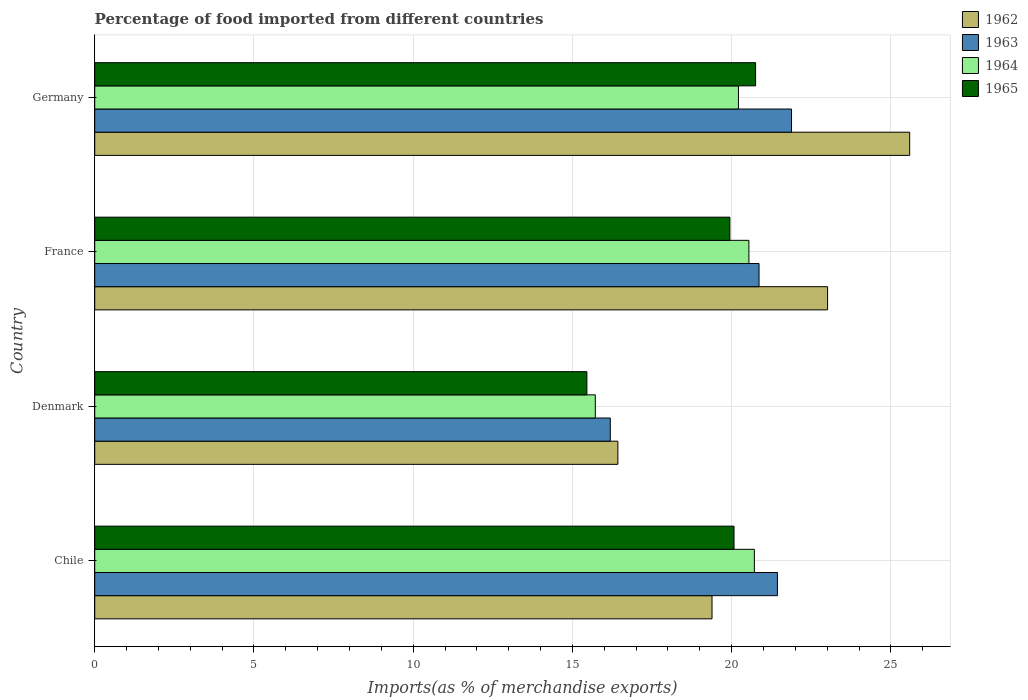Are the number of bars per tick equal to the number of legend labels?
Provide a succinct answer. Yes. Are the number of bars on each tick of the Y-axis equal?
Ensure brevity in your answer.  Yes. What is the label of the 4th group of bars from the top?
Ensure brevity in your answer.  Chile. What is the percentage of imports to different countries in 1964 in Germany?
Your answer should be compact. 20.21. Across all countries, what is the maximum percentage of imports to different countries in 1963?
Give a very brief answer. 21.88. Across all countries, what is the minimum percentage of imports to different countries in 1962?
Give a very brief answer. 16.43. In which country was the percentage of imports to different countries in 1962 minimum?
Keep it short and to the point. Denmark. What is the total percentage of imports to different countries in 1964 in the graph?
Offer a terse response. 77.18. What is the difference between the percentage of imports to different countries in 1964 in Chile and that in Denmark?
Provide a short and direct response. 4.99. What is the difference between the percentage of imports to different countries in 1963 in Chile and the percentage of imports to different countries in 1964 in Germany?
Your answer should be compact. 1.22. What is the average percentage of imports to different countries in 1963 per country?
Ensure brevity in your answer.  20.09. What is the difference between the percentage of imports to different countries in 1964 and percentage of imports to different countries in 1965 in Germany?
Your answer should be compact. -0.54. In how many countries, is the percentage of imports to different countries in 1962 greater than 13 %?
Provide a succinct answer. 4. What is the ratio of the percentage of imports to different countries in 1962 in Denmark to that in Germany?
Provide a short and direct response. 0.64. Is the difference between the percentage of imports to different countries in 1964 in Chile and Denmark greater than the difference between the percentage of imports to different countries in 1965 in Chile and Denmark?
Give a very brief answer. Yes. What is the difference between the highest and the second highest percentage of imports to different countries in 1962?
Keep it short and to the point. 2.58. What is the difference between the highest and the lowest percentage of imports to different countries in 1963?
Your answer should be very brief. 5.69. In how many countries, is the percentage of imports to different countries in 1963 greater than the average percentage of imports to different countries in 1963 taken over all countries?
Make the answer very short. 3. What does the 4th bar from the top in Germany represents?
Give a very brief answer. 1962. What does the 3rd bar from the bottom in Denmark represents?
Ensure brevity in your answer.  1964. Are all the bars in the graph horizontal?
Give a very brief answer. Yes. How many countries are there in the graph?
Offer a very short reply. 4. What is the difference between two consecutive major ticks on the X-axis?
Make the answer very short. 5. Where does the legend appear in the graph?
Offer a terse response. Top right. How many legend labels are there?
Provide a short and direct response. 4. How are the legend labels stacked?
Make the answer very short. Vertical. What is the title of the graph?
Your response must be concise. Percentage of food imported from different countries. What is the label or title of the X-axis?
Your response must be concise. Imports(as % of merchandise exports). What is the label or title of the Y-axis?
Your answer should be compact. Country. What is the Imports(as % of merchandise exports) in 1962 in Chile?
Give a very brief answer. 19.38. What is the Imports(as % of merchandise exports) of 1963 in Chile?
Offer a terse response. 21.44. What is the Imports(as % of merchandise exports) in 1964 in Chile?
Make the answer very short. 20.71. What is the Imports(as % of merchandise exports) in 1965 in Chile?
Offer a very short reply. 20.07. What is the Imports(as % of merchandise exports) of 1962 in Denmark?
Provide a short and direct response. 16.43. What is the Imports(as % of merchandise exports) of 1963 in Denmark?
Your answer should be compact. 16.19. What is the Imports(as % of merchandise exports) in 1964 in Denmark?
Keep it short and to the point. 15.72. What is the Imports(as % of merchandise exports) in 1965 in Denmark?
Your answer should be very brief. 15.45. What is the Imports(as % of merchandise exports) in 1962 in France?
Make the answer very short. 23.01. What is the Imports(as % of merchandise exports) in 1963 in France?
Provide a short and direct response. 20.86. What is the Imports(as % of merchandise exports) of 1964 in France?
Make the answer very short. 20.54. What is the Imports(as % of merchandise exports) of 1965 in France?
Your response must be concise. 19.94. What is the Imports(as % of merchandise exports) of 1962 in Germany?
Provide a short and direct response. 25.59. What is the Imports(as % of merchandise exports) of 1963 in Germany?
Give a very brief answer. 21.88. What is the Imports(as % of merchandise exports) of 1964 in Germany?
Your answer should be compact. 20.21. What is the Imports(as % of merchandise exports) of 1965 in Germany?
Your answer should be compact. 20.75. Across all countries, what is the maximum Imports(as % of merchandise exports) in 1962?
Ensure brevity in your answer.  25.59. Across all countries, what is the maximum Imports(as % of merchandise exports) in 1963?
Your answer should be very brief. 21.88. Across all countries, what is the maximum Imports(as % of merchandise exports) of 1964?
Provide a succinct answer. 20.71. Across all countries, what is the maximum Imports(as % of merchandise exports) of 1965?
Keep it short and to the point. 20.75. Across all countries, what is the minimum Imports(as % of merchandise exports) in 1962?
Your answer should be very brief. 16.43. Across all countries, what is the minimum Imports(as % of merchandise exports) in 1963?
Give a very brief answer. 16.19. Across all countries, what is the minimum Imports(as % of merchandise exports) of 1964?
Keep it short and to the point. 15.72. Across all countries, what is the minimum Imports(as % of merchandise exports) in 1965?
Ensure brevity in your answer.  15.45. What is the total Imports(as % of merchandise exports) of 1962 in the graph?
Ensure brevity in your answer.  84.41. What is the total Imports(as % of merchandise exports) in 1963 in the graph?
Keep it short and to the point. 80.36. What is the total Imports(as % of merchandise exports) in 1964 in the graph?
Your answer should be compact. 77.18. What is the total Imports(as % of merchandise exports) of 1965 in the graph?
Offer a very short reply. 76.22. What is the difference between the Imports(as % of merchandise exports) in 1962 in Chile and that in Denmark?
Offer a terse response. 2.96. What is the difference between the Imports(as % of merchandise exports) of 1963 in Chile and that in Denmark?
Your response must be concise. 5.25. What is the difference between the Imports(as % of merchandise exports) in 1964 in Chile and that in Denmark?
Give a very brief answer. 4.99. What is the difference between the Imports(as % of merchandise exports) in 1965 in Chile and that in Denmark?
Your response must be concise. 4.62. What is the difference between the Imports(as % of merchandise exports) in 1962 in Chile and that in France?
Your answer should be compact. -3.63. What is the difference between the Imports(as % of merchandise exports) in 1963 in Chile and that in France?
Keep it short and to the point. 0.58. What is the difference between the Imports(as % of merchandise exports) in 1964 in Chile and that in France?
Provide a short and direct response. 0.17. What is the difference between the Imports(as % of merchandise exports) in 1965 in Chile and that in France?
Your answer should be compact. 0.13. What is the difference between the Imports(as % of merchandise exports) of 1962 in Chile and that in Germany?
Your answer should be compact. -6.21. What is the difference between the Imports(as % of merchandise exports) of 1963 in Chile and that in Germany?
Make the answer very short. -0.44. What is the difference between the Imports(as % of merchandise exports) of 1964 in Chile and that in Germany?
Your response must be concise. 0.5. What is the difference between the Imports(as % of merchandise exports) in 1965 in Chile and that in Germany?
Provide a succinct answer. -0.68. What is the difference between the Imports(as % of merchandise exports) of 1962 in Denmark and that in France?
Ensure brevity in your answer.  -6.59. What is the difference between the Imports(as % of merchandise exports) of 1963 in Denmark and that in France?
Provide a short and direct response. -4.67. What is the difference between the Imports(as % of merchandise exports) of 1964 in Denmark and that in France?
Your answer should be compact. -4.82. What is the difference between the Imports(as % of merchandise exports) in 1965 in Denmark and that in France?
Offer a very short reply. -4.49. What is the difference between the Imports(as % of merchandise exports) in 1962 in Denmark and that in Germany?
Provide a short and direct response. -9.16. What is the difference between the Imports(as % of merchandise exports) of 1963 in Denmark and that in Germany?
Your answer should be compact. -5.69. What is the difference between the Imports(as % of merchandise exports) of 1964 in Denmark and that in Germany?
Offer a very short reply. -4.49. What is the difference between the Imports(as % of merchandise exports) in 1965 in Denmark and that in Germany?
Your answer should be very brief. -5.3. What is the difference between the Imports(as % of merchandise exports) in 1962 in France and that in Germany?
Your answer should be compact. -2.58. What is the difference between the Imports(as % of merchandise exports) of 1963 in France and that in Germany?
Your answer should be very brief. -1.02. What is the difference between the Imports(as % of merchandise exports) of 1964 in France and that in Germany?
Give a very brief answer. 0.33. What is the difference between the Imports(as % of merchandise exports) in 1965 in France and that in Germany?
Ensure brevity in your answer.  -0.81. What is the difference between the Imports(as % of merchandise exports) in 1962 in Chile and the Imports(as % of merchandise exports) in 1963 in Denmark?
Keep it short and to the point. 3.19. What is the difference between the Imports(as % of merchandise exports) in 1962 in Chile and the Imports(as % of merchandise exports) in 1964 in Denmark?
Keep it short and to the point. 3.66. What is the difference between the Imports(as % of merchandise exports) of 1962 in Chile and the Imports(as % of merchandise exports) of 1965 in Denmark?
Your answer should be very brief. 3.93. What is the difference between the Imports(as % of merchandise exports) of 1963 in Chile and the Imports(as % of merchandise exports) of 1964 in Denmark?
Provide a succinct answer. 5.72. What is the difference between the Imports(as % of merchandise exports) in 1963 in Chile and the Imports(as % of merchandise exports) in 1965 in Denmark?
Give a very brief answer. 5.98. What is the difference between the Imports(as % of merchandise exports) in 1964 in Chile and the Imports(as % of merchandise exports) in 1965 in Denmark?
Offer a terse response. 5.26. What is the difference between the Imports(as % of merchandise exports) in 1962 in Chile and the Imports(as % of merchandise exports) in 1963 in France?
Keep it short and to the point. -1.48. What is the difference between the Imports(as % of merchandise exports) in 1962 in Chile and the Imports(as % of merchandise exports) in 1964 in France?
Give a very brief answer. -1.16. What is the difference between the Imports(as % of merchandise exports) of 1962 in Chile and the Imports(as % of merchandise exports) of 1965 in France?
Offer a very short reply. -0.56. What is the difference between the Imports(as % of merchandise exports) of 1963 in Chile and the Imports(as % of merchandise exports) of 1964 in France?
Provide a short and direct response. 0.9. What is the difference between the Imports(as % of merchandise exports) in 1963 in Chile and the Imports(as % of merchandise exports) in 1965 in France?
Your answer should be compact. 1.49. What is the difference between the Imports(as % of merchandise exports) in 1964 in Chile and the Imports(as % of merchandise exports) in 1965 in France?
Provide a succinct answer. 0.77. What is the difference between the Imports(as % of merchandise exports) of 1962 in Chile and the Imports(as % of merchandise exports) of 1963 in Germany?
Ensure brevity in your answer.  -2.5. What is the difference between the Imports(as % of merchandise exports) in 1962 in Chile and the Imports(as % of merchandise exports) in 1964 in Germany?
Make the answer very short. -0.83. What is the difference between the Imports(as % of merchandise exports) of 1962 in Chile and the Imports(as % of merchandise exports) of 1965 in Germany?
Make the answer very short. -1.37. What is the difference between the Imports(as % of merchandise exports) in 1963 in Chile and the Imports(as % of merchandise exports) in 1964 in Germany?
Give a very brief answer. 1.22. What is the difference between the Imports(as % of merchandise exports) in 1963 in Chile and the Imports(as % of merchandise exports) in 1965 in Germany?
Your answer should be compact. 0.69. What is the difference between the Imports(as % of merchandise exports) in 1964 in Chile and the Imports(as % of merchandise exports) in 1965 in Germany?
Give a very brief answer. -0.04. What is the difference between the Imports(as % of merchandise exports) in 1962 in Denmark and the Imports(as % of merchandise exports) in 1963 in France?
Keep it short and to the point. -4.43. What is the difference between the Imports(as % of merchandise exports) in 1962 in Denmark and the Imports(as % of merchandise exports) in 1964 in France?
Ensure brevity in your answer.  -4.11. What is the difference between the Imports(as % of merchandise exports) in 1962 in Denmark and the Imports(as % of merchandise exports) in 1965 in France?
Your answer should be compact. -3.52. What is the difference between the Imports(as % of merchandise exports) in 1963 in Denmark and the Imports(as % of merchandise exports) in 1964 in France?
Offer a very short reply. -4.35. What is the difference between the Imports(as % of merchandise exports) of 1963 in Denmark and the Imports(as % of merchandise exports) of 1965 in France?
Provide a succinct answer. -3.76. What is the difference between the Imports(as % of merchandise exports) in 1964 in Denmark and the Imports(as % of merchandise exports) in 1965 in France?
Give a very brief answer. -4.23. What is the difference between the Imports(as % of merchandise exports) of 1962 in Denmark and the Imports(as % of merchandise exports) of 1963 in Germany?
Keep it short and to the point. -5.45. What is the difference between the Imports(as % of merchandise exports) of 1962 in Denmark and the Imports(as % of merchandise exports) of 1964 in Germany?
Offer a very short reply. -3.79. What is the difference between the Imports(as % of merchandise exports) in 1962 in Denmark and the Imports(as % of merchandise exports) in 1965 in Germany?
Provide a succinct answer. -4.32. What is the difference between the Imports(as % of merchandise exports) of 1963 in Denmark and the Imports(as % of merchandise exports) of 1964 in Germany?
Offer a very short reply. -4.02. What is the difference between the Imports(as % of merchandise exports) in 1963 in Denmark and the Imports(as % of merchandise exports) in 1965 in Germany?
Ensure brevity in your answer.  -4.56. What is the difference between the Imports(as % of merchandise exports) of 1964 in Denmark and the Imports(as % of merchandise exports) of 1965 in Germany?
Your response must be concise. -5.03. What is the difference between the Imports(as % of merchandise exports) in 1962 in France and the Imports(as % of merchandise exports) in 1963 in Germany?
Give a very brief answer. 1.13. What is the difference between the Imports(as % of merchandise exports) in 1962 in France and the Imports(as % of merchandise exports) in 1964 in Germany?
Give a very brief answer. 2.8. What is the difference between the Imports(as % of merchandise exports) in 1962 in France and the Imports(as % of merchandise exports) in 1965 in Germany?
Offer a very short reply. 2.26. What is the difference between the Imports(as % of merchandise exports) of 1963 in France and the Imports(as % of merchandise exports) of 1964 in Germany?
Offer a very short reply. 0.65. What is the difference between the Imports(as % of merchandise exports) of 1963 in France and the Imports(as % of merchandise exports) of 1965 in Germany?
Offer a very short reply. 0.11. What is the difference between the Imports(as % of merchandise exports) of 1964 in France and the Imports(as % of merchandise exports) of 1965 in Germany?
Ensure brevity in your answer.  -0.21. What is the average Imports(as % of merchandise exports) of 1962 per country?
Make the answer very short. 21.1. What is the average Imports(as % of merchandise exports) of 1963 per country?
Give a very brief answer. 20.09. What is the average Imports(as % of merchandise exports) in 1964 per country?
Offer a very short reply. 19.3. What is the average Imports(as % of merchandise exports) in 1965 per country?
Provide a succinct answer. 19.06. What is the difference between the Imports(as % of merchandise exports) in 1962 and Imports(as % of merchandise exports) in 1963 in Chile?
Provide a succinct answer. -2.05. What is the difference between the Imports(as % of merchandise exports) of 1962 and Imports(as % of merchandise exports) of 1964 in Chile?
Give a very brief answer. -1.33. What is the difference between the Imports(as % of merchandise exports) in 1962 and Imports(as % of merchandise exports) in 1965 in Chile?
Provide a succinct answer. -0.69. What is the difference between the Imports(as % of merchandise exports) of 1963 and Imports(as % of merchandise exports) of 1964 in Chile?
Offer a very short reply. 0.72. What is the difference between the Imports(as % of merchandise exports) in 1963 and Imports(as % of merchandise exports) in 1965 in Chile?
Provide a succinct answer. 1.36. What is the difference between the Imports(as % of merchandise exports) of 1964 and Imports(as % of merchandise exports) of 1965 in Chile?
Provide a succinct answer. 0.64. What is the difference between the Imports(as % of merchandise exports) in 1962 and Imports(as % of merchandise exports) in 1963 in Denmark?
Keep it short and to the point. 0.24. What is the difference between the Imports(as % of merchandise exports) in 1962 and Imports(as % of merchandise exports) in 1964 in Denmark?
Make the answer very short. 0.71. What is the difference between the Imports(as % of merchandise exports) in 1962 and Imports(as % of merchandise exports) in 1965 in Denmark?
Give a very brief answer. 0.97. What is the difference between the Imports(as % of merchandise exports) in 1963 and Imports(as % of merchandise exports) in 1964 in Denmark?
Ensure brevity in your answer.  0.47. What is the difference between the Imports(as % of merchandise exports) in 1963 and Imports(as % of merchandise exports) in 1965 in Denmark?
Ensure brevity in your answer.  0.73. What is the difference between the Imports(as % of merchandise exports) in 1964 and Imports(as % of merchandise exports) in 1965 in Denmark?
Your response must be concise. 0.26. What is the difference between the Imports(as % of merchandise exports) of 1962 and Imports(as % of merchandise exports) of 1963 in France?
Your answer should be very brief. 2.15. What is the difference between the Imports(as % of merchandise exports) of 1962 and Imports(as % of merchandise exports) of 1964 in France?
Your response must be concise. 2.47. What is the difference between the Imports(as % of merchandise exports) in 1962 and Imports(as % of merchandise exports) in 1965 in France?
Offer a very short reply. 3.07. What is the difference between the Imports(as % of merchandise exports) of 1963 and Imports(as % of merchandise exports) of 1964 in France?
Your answer should be very brief. 0.32. What is the difference between the Imports(as % of merchandise exports) of 1963 and Imports(as % of merchandise exports) of 1965 in France?
Your answer should be very brief. 0.92. What is the difference between the Imports(as % of merchandise exports) in 1964 and Imports(as % of merchandise exports) in 1965 in France?
Give a very brief answer. 0.6. What is the difference between the Imports(as % of merchandise exports) in 1962 and Imports(as % of merchandise exports) in 1963 in Germany?
Offer a very short reply. 3.71. What is the difference between the Imports(as % of merchandise exports) of 1962 and Imports(as % of merchandise exports) of 1964 in Germany?
Your response must be concise. 5.38. What is the difference between the Imports(as % of merchandise exports) in 1962 and Imports(as % of merchandise exports) in 1965 in Germany?
Provide a short and direct response. 4.84. What is the difference between the Imports(as % of merchandise exports) of 1963 and Imports(as % of merchandise exports) of 1964 in Germany?
Provide a short and direct response. 1.67. What is the difference between the Imports(as % of merchandise exports) in 1963 and Imports(as % of merchandise exports) in 1965 in Germany?
Keep it short and to the point. 1.13. What is the difference between the Imports(as % of merchandise exports) in 1964 and Imports(as % of merchandise exports) in 1965 in Germany?
Your answer should be very brief. -0.54. What is the ratio of the Imports(as % of merchandise exports) of 1962 in Chile to that in Denmark?
Give a very brief answer. 1.18. What is the ratio of the Imports(as % of merchandise exports) in 1963 in Chile to that in Denmark?
Give a very brief answer. 1.32. What is the ratio of the Imports(as % of merchandise exports) of 1964 in Chile to that in Denmark?
Ensure brevity in your answer.  1.32. What is the ratio of the Imports(as % of merchandise exports) of 1965 in Chile to that in Denmark?
Provide a short and direct response. 1.3. What is the ratio of the Imports(as % of merchandise exports) in 1962 in Chile to that in France?
Your answer should be compact. 0.84. What is the ratio of the Imports(as % of merchandise exports) of 1963 in Chile to that in France?
Your response must be concise. 1.03. What is the ratio of the Imports(as % of merchandise exports) of 1964 in Chile to that in France?
Provide a succinct answer. 1.01. What is the ratio of the Imports(as % of merchandise exports) of 1962 in Chile to that in Germany?
Make the answer very short. 0.76. What is the ratio of the Imports(as % of merchandise exports) of 1963 in Chile to that in Germany?
Your response must be concise. 0.98. What is the ratio of the Imports(as % of merchandise exports) in 1964 in Chile to that in Germany?
Ensure brevity in your answer.  1.02. What is the ratio of the Imports(as % of merchandise exports) in 1965 in Chile to that in Germany?
Give a very brief answer. 0.97. What is the ratio of the Imports(as % of merchandise exports) in 1962 in Denmark to that in France?
Offer a terse response. 0.71. What is the ratio of the Imports(as % of merchandise exports) of 1963 in Denmark to that in France?
Give a very brief answer. 0.78. What is the ratio of the Imports(as % of merchandise exports) of 1964 in Denmark to that in France?
Offer a terse response. 0.77. What is the ratio of the Imports(as % of merchandise exports) of 1965 in Denmark to that in France?
Provide a short and direct response. 0.77. What is the ratio of the Imports(as % of merchandise exports) in 1962 in Denmark to that in Germany?
Ensure brevity in your answer.  0.64. What is the ratio of the Imports(as % of merchandise exports) of 1963 in Denmark to that in Germany?
Provide a succinct answer. 0.74. What is the ratio of the Imports(as % of merchandise exports) in 1964 in Denmark to that in Germany?
Keep it short and to the point. 0.78. What is the ratio of the Imports(as % of merchandise exports) in 1965 in Denmark to that in Germany?
Offer a terse response. 0.74. What is the ratio of the Imports(as % of merchandise exports) in 1962 in France to that in Germany?
Your answer should be very brief. 0.9. What is the ratio of the Imports(as % of merchandise exports) in 1963 in France to that in Germany?
Offer a terse response. 0.95. What is the ratio of the Imports(as % of merchandise exports) in 1964 in France to that in Germany?
Your response must be concise. 1.02. What is the ratio of the Imports(as % of merchandise exports) in 1965 in France to that in Germany?
Offer a terse response. 0.96. What is the difference between the highest and the second highest Imports(as % of merchandise exports) of 1962?
Your response must be concise. 2.58. What is the difference between the highest and the second highest Imports(as % of merchandise exports) in 1963?
Ensure brevity in your answer.  0.44. What is the difference between the highest and the second highest Imports(as % of merchandise exports) in 1964?
Your response must be concise. 0.17. What is the difference between the highest and the second highest Imports(as % of merchandise exports) in 1965?
Give a very brief answer. 0.68. What is the difference between the highest and the lowest Imports(as % of merchandise exports) in 1962?
Give a very brief answer. 9.16. What is the difference between the highest and the lowest Imports(as % of merchandise exports) of 1963?
Your answer should be compact. 5.69. What is the difference between the highest and the lowest Imports(as % of merchandise exports) of 1964?
Offer a very short reply. 4.99. What is the difference between the highest and the lowest Imports(as % of merchandise exports) of 1965?
Make the answer very short. 5.3. 